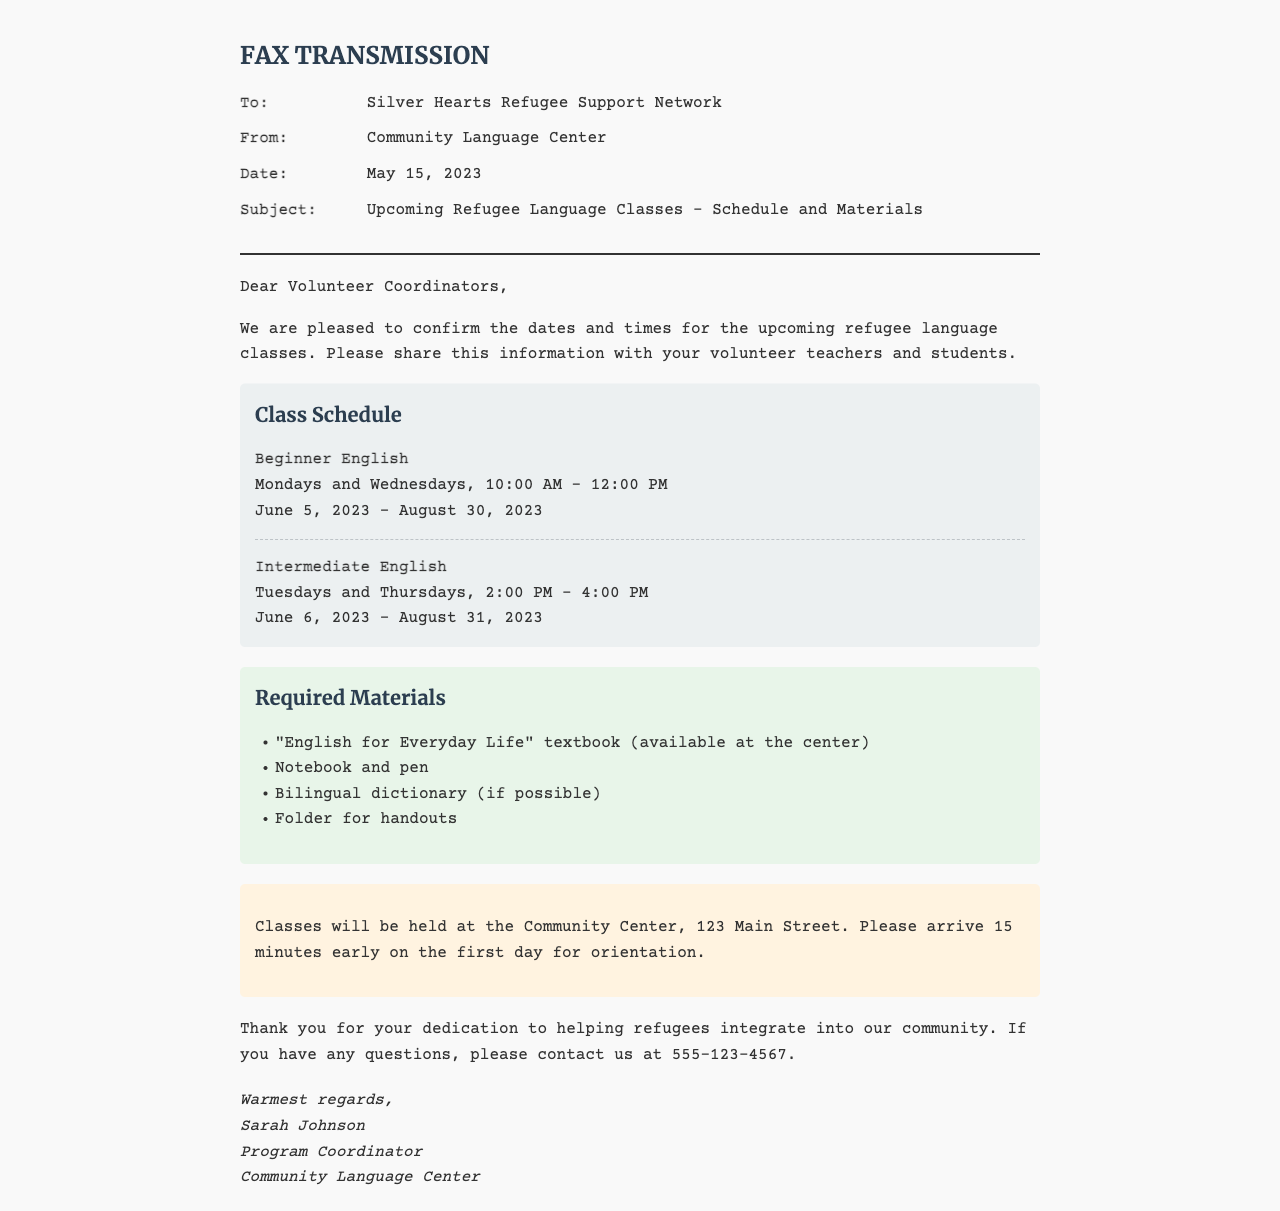What are the class days for Beginner English? The schedule indicates that Beginner English classes are held on Mondays and Wednesdays.
Answer: Mondays and Wednesdays What is the duration of the Beginner English class? The document specifies that the Beginner English class runs from June 5, 2023, to August 30, 2023.
Answer: June 5, 2023 - August 30, 2023 What time does the Intermediate English class start? The document states that the Intermediate English class starts at 2:00 PM.
Answer: 2:00 PM How many required materials are listed? The list of required materials includes four items.
Answer: Four Where will the classes be held? The document mentions that classes will be held at the Community Center.
Answer: Community Center What should students bring for orientation on the first day? The document advises arriving 15 minutes early for orientation on the first day.
Answer: 15 minutes early What is the phone number provided for questions? The document includes a contact number for questions as 555-123-4567.
Answer: 555-123-4567 Who is the Program Coordinator? The signature section of the document indicates that Sarah Johnson is the Program Coordinator.
Answer: Sarah Johnson 